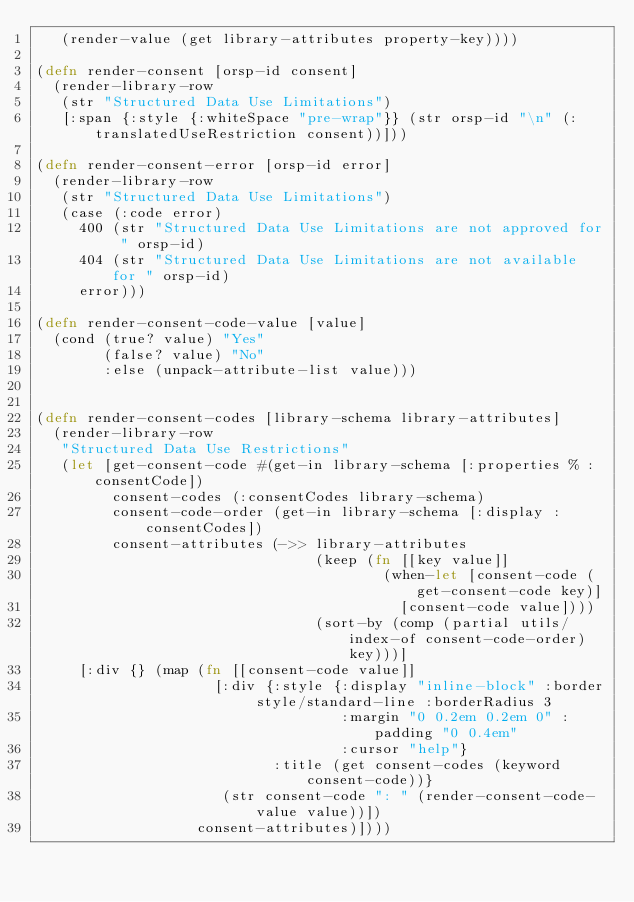<code> <loc_0><loc_0><loc_500><loc_500><_Clojure_>   (render-value (get library-attributes property-key))))

(defn render-consent [orsp-id consent]
  (render-library-row
   (str "Structured Data Use Limitations")
   [:span {:style {:whiteSpace "pre-wrap"}} (str orsp-id "\n" (:translatedUseRestriction consent))]))

(defn render-consent-error [orsp-id error]
  (render-library-row
   (str "Structured Data Use Limitations")
   (case (:code error)
     400 (str "Structured Data Use Limitations are not approved for " orsp-id)
     404 (str "Structured Data Use Limitations are not available for " orsp-id)
     error)))

(defn render-consent-code-value [value]
  (cond (true? value) "Yes"
        (false? value) "No"
        :else (unpack-attribute-list value)))


(defn render-consent-codes [library-schema library-attributes]
  (render-library-row
   "Structured Data Use Restrictions"
   (let [get-consent-code #(get-in library-schema [:properties % :consentCode])
         consent-codes (:consentCodes library-schema)
         consent-code-order (get-in library-schema [:display :consentCodes])
         consent-attributes (->> library-attributes
                                 (keep (fn [[key value]]
                                         (when-let [consent-code (get-consent-code key)]
                                           [consent-code value])))
                                 (sort-by (comp (partial utils/index-of consent-code-order) key)))]
     [:div {} (map (fn [[consent-code value]]
                     [:div {:style {:display "inline-block" :border style/standard-line :borderRadius 3
                                    :margin "0 0.2em 0.2em 0" :padding "0 0.4em"
                                    :cursor "help"}
                            :title (get consent-codes (keyword consent-code))}
                      (str consent-code ": " (render-consent-code-value value))])
                   consent-attributes)])))
</code> 